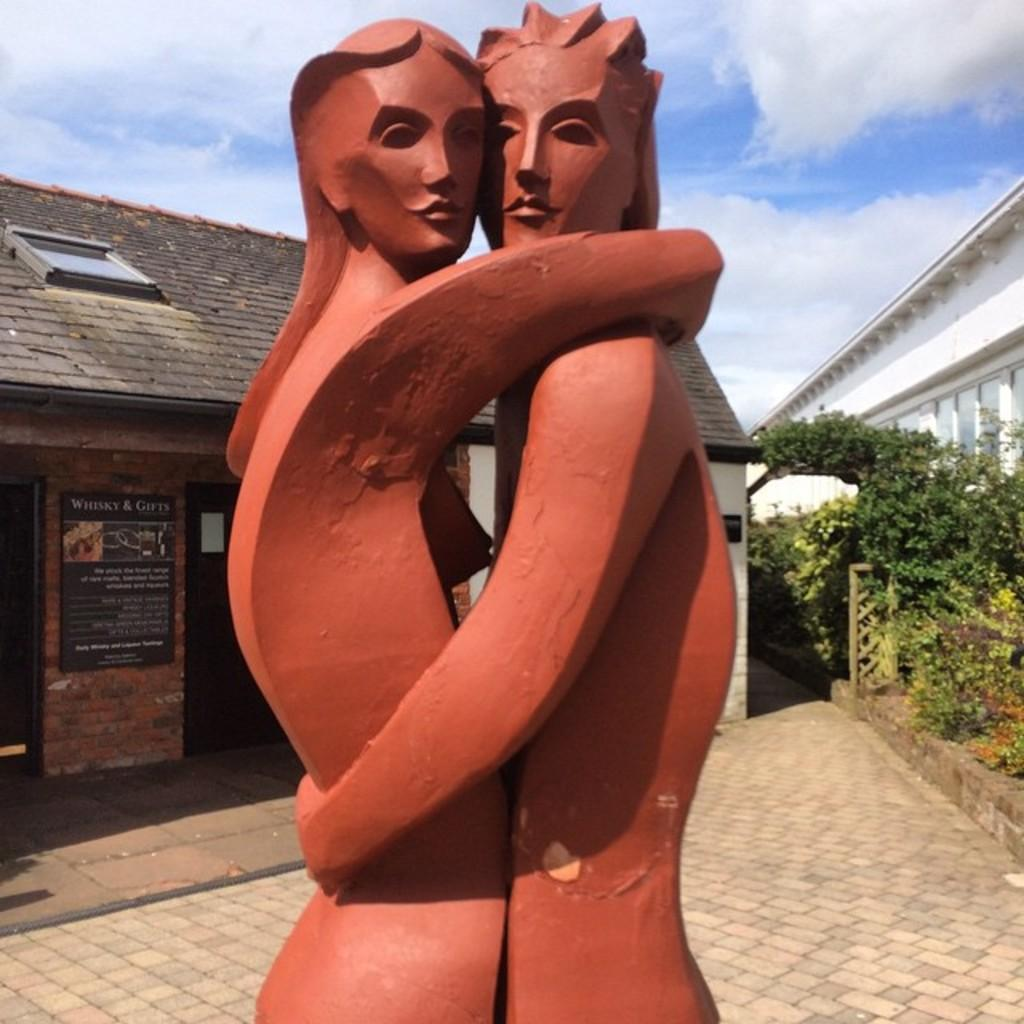What is the main subject in the image? There is a statue in the image. What color is the statue? The statue is brown in color. What can be seen in the background of the image? There are buildings visible in the background. What is attached to a wall in the image? A board is attached to a wall. What colors are visible in the sky in the image? The sky is blue and white in color. How many oranges are placed on the statue in the image? There are no oranges present on the statue in the image. What level of detail can be seen on the statue in the image? The level of detail on the statue cannot be determined from the image alone, as the resolution or quality of the image may affect the visibility of such details. 